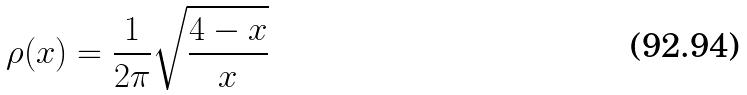<formula> <loc_0><loc_0><loc_500><loc_500>\rho ( x ) = \frac { 1 } { 2 \pi } \sqrt { \frac { 4 - x } { x } }</formula> 